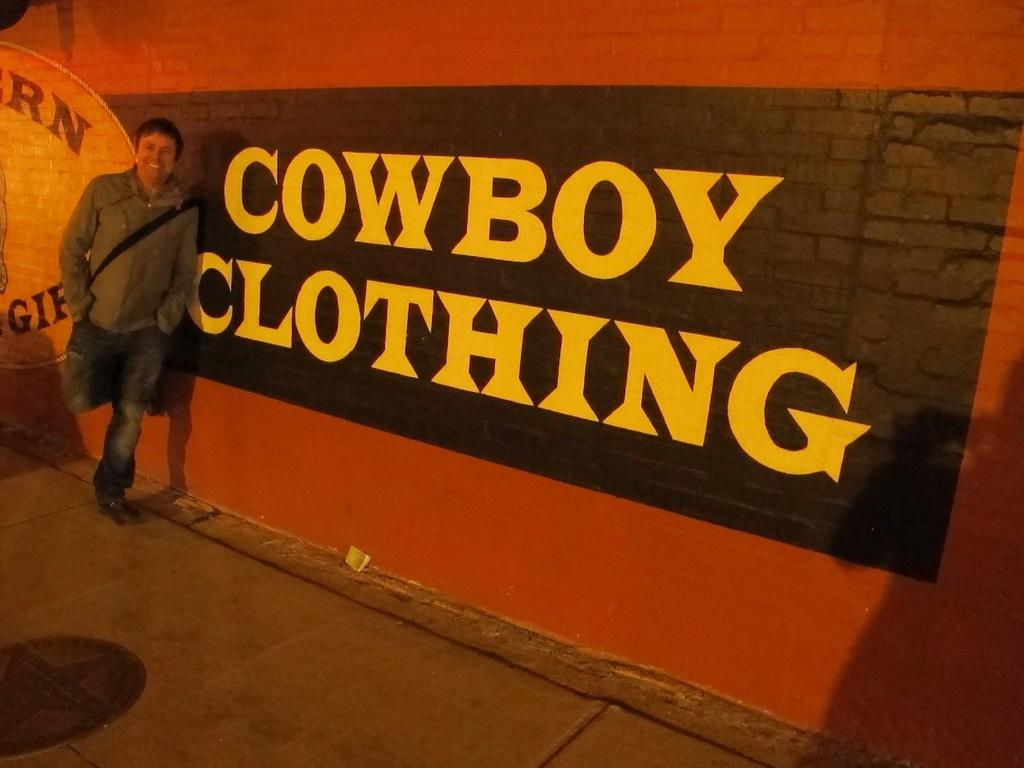Who is present in the image? There is a man in the image. What is the man wearing? The man is wearing a gray jacket. What is the man's posture in the image? The man is standing. What can be seen on the wall in the image? There is a text and a painting on the wall in the image. What is visible under the man's feet in the image? There is a floor visible in the image. What is the man carrying in the image? The man is wearing a bag. What type of drum can be heard playing in the background of the image? There is no drum or sound present in the image; it is a still image of a man standing with a gray jacket and a bag. 